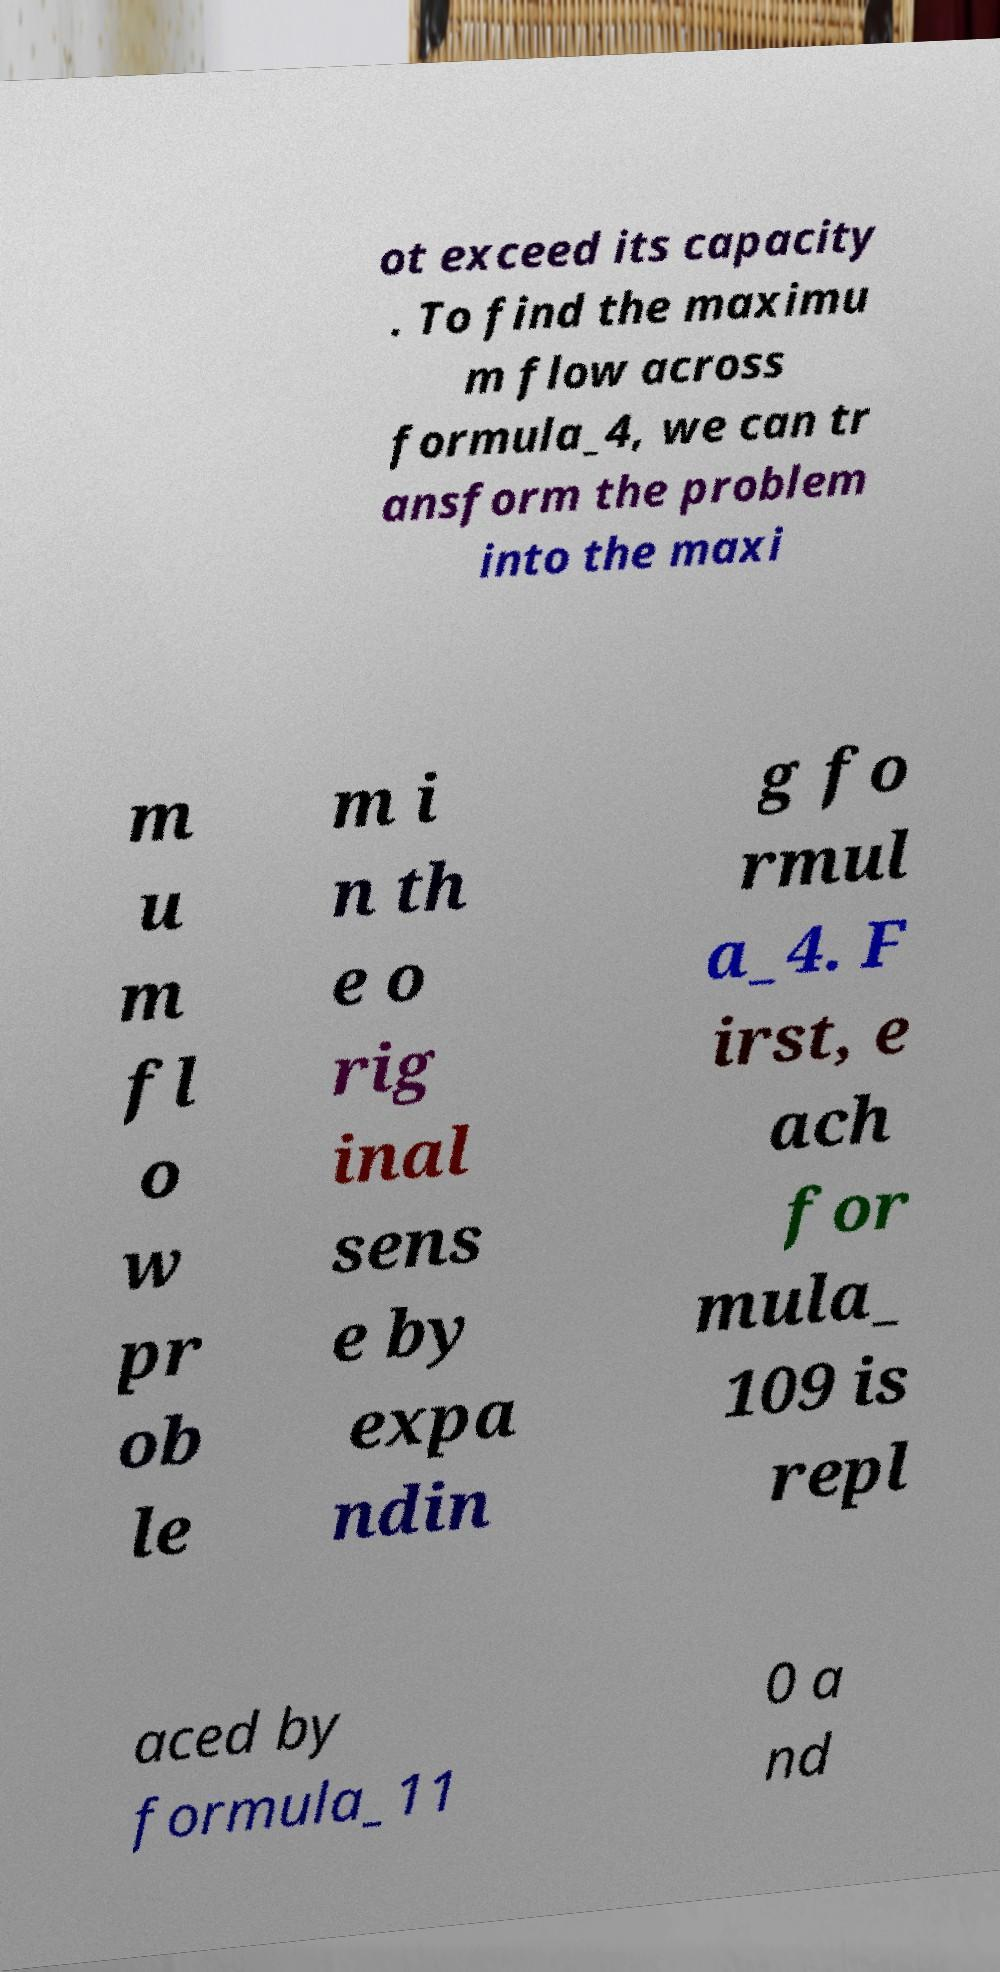I need the written content from this picture converted into text. Can you do that? ot exceed its capacity . To find the maximu m flow across formula_4, we can tr ansform the problem into the maxi m u m fl o w pr ob le m i n th e o rig inal sens e by expa ndin g fo rmul a_4. F irst, e ach for mula_ 109 is repl aced by formula_11 0 a nd 